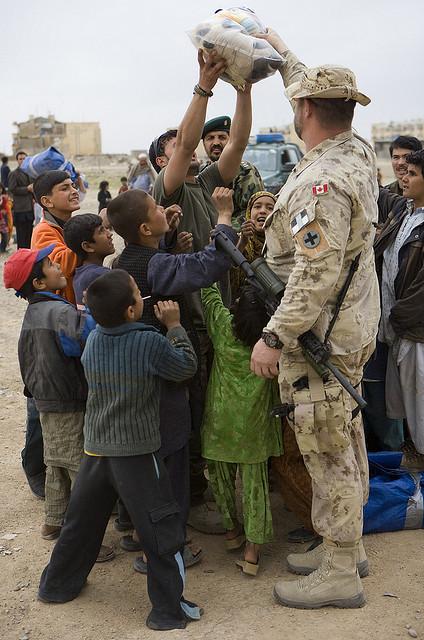Is the man an army?
Concise answer only. Yes. What is the man holding in his hand?
Answer briefly. Food. Is this man in New York?
Keep it brief. No. 